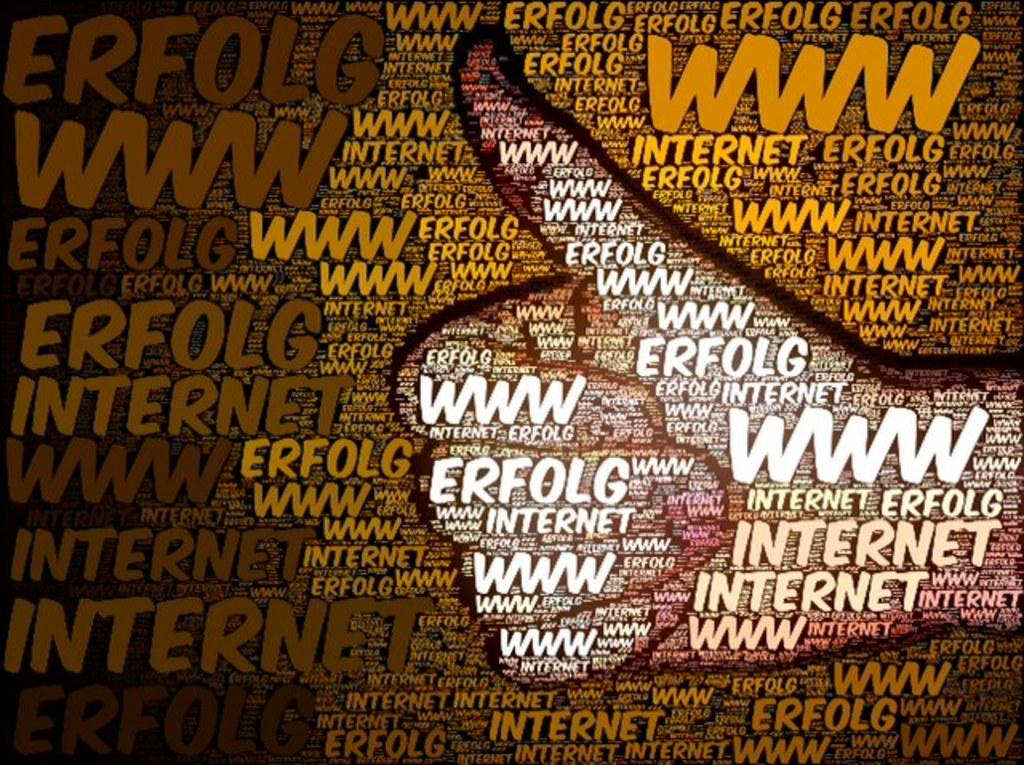<image>
Render a clear and concise summary of the photo. A letter mosaic of a thumbs up with the web address to erfolg internet. 